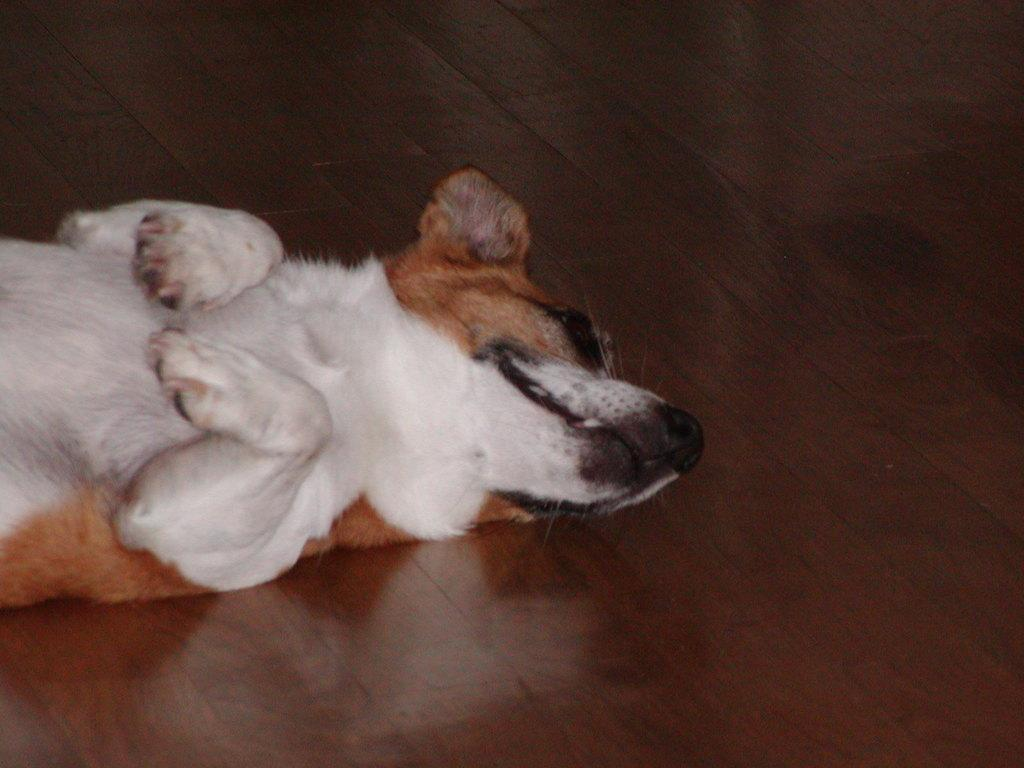What animal is present in the image? There is a dog in the image. On which side of the image is the dog located? The dog is on the left side of the image. What type of surface is the dog lying on? The dog is lying on a wooden surface. How many squirrels are interacting with the dog in the image? There are no squirrels present in the image. What is the cause of the dog's death in the image? There is no indication of the dog's death in the image, as the dog is lying on a wooden surface. 